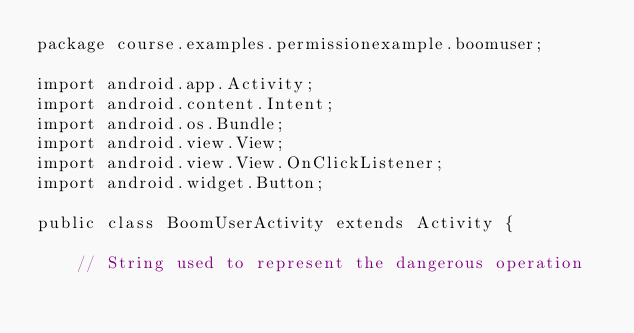<code> <loc_0><loc_0><loc_500><loc_500><_Java_>package course.examples.permissionexample.boomuser;

import android.app.Activity;
import android.content.Intent;
import android.os.Bundle;
import android.view.View;
import android.view.View.OnClickListener;
import android.widget.Button;

public class BoomUserActivity extends Activity {

	// String used to represent the dangerous operation</code> 